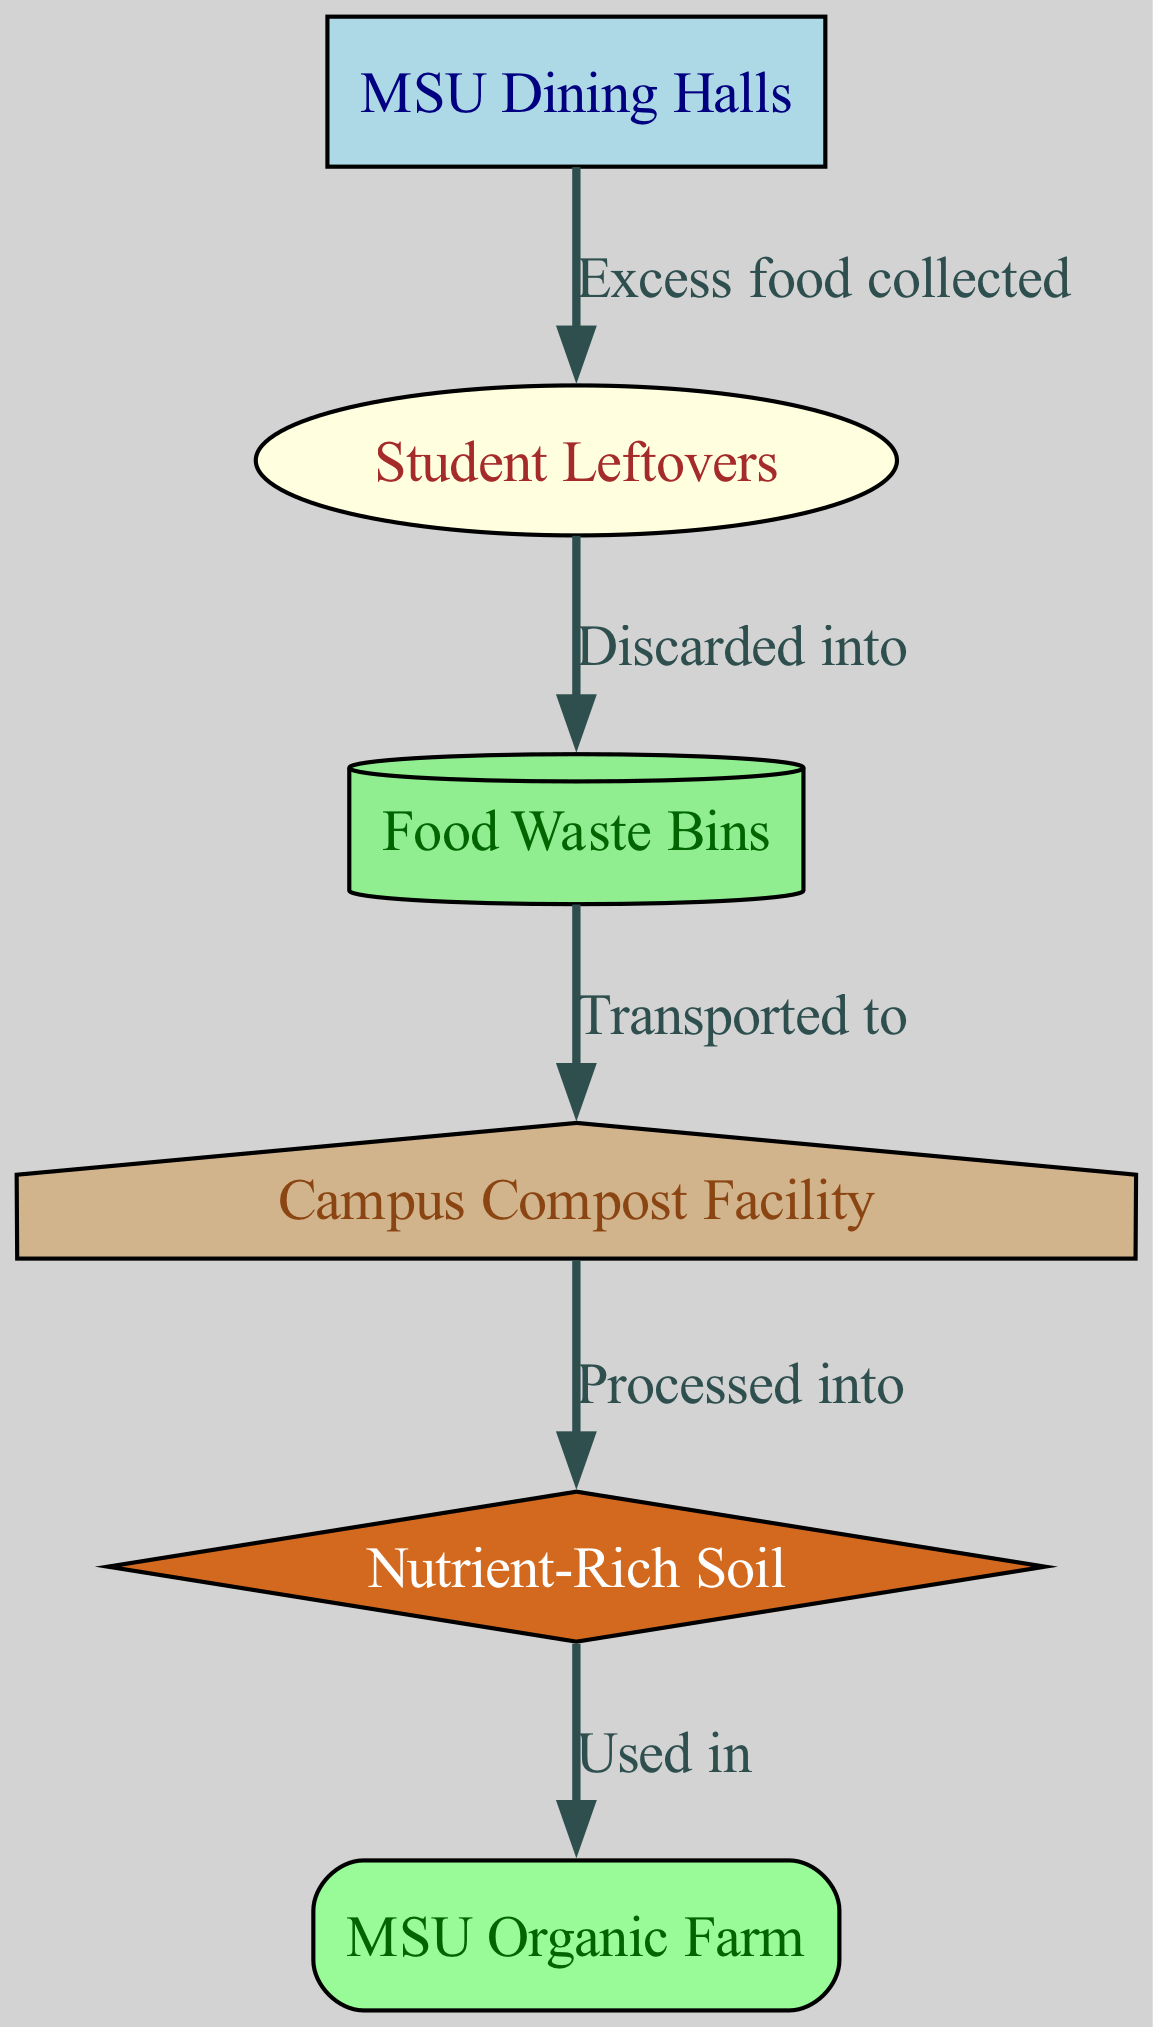What is the first node in the food waste cycle? The first node in the cycle is identified as the starting point of the diagram, which is labeled "MSU Dining Halls."
Answer: MSU Dining Halls How many nodes are present in the diagram? To determine the number of nodes, we count each unique location or step listed in the nodes section. There are six nodes: MSU Dining Halls, Student Leftovers, Food Waste Bins, Campus Compost Facility, Nutrient-Rich Soil, and MSU Organic Farm.
Answer: 6 What relationship occurs between "Student Leftovers" and "Food Waste Bins"? The relationship between "Student Leftovers" and "Food Waste Bins" is defined by the edge labeled "Discarded into," indicating that leftovers are disposed of in waste bins.
Answer: Discarded into Which node is processed to create "Nutrient-Rich Soil"? The node that is processed to create "Nutrient-Rich Soil" is the "Campus Compost Facility," as indicated by the flow that shows processing leads to the creation of nutrient-rich soil.
Answer: Campus Compost Facility What step follows after "Food Waste Bins"? After "Food Waste Bins," the next step indicated in the flow diagram is that the waste is "Transported to" the "Campus Compost Facility," which is the direct progression from the waste bins.
Answer: Transported to Which node utilizes "Nutrient-Rich Soil"? The node that utilizes "Nutrient-Rich Soil" is the "MSU Organic Farm," as represented in the final step of the diagram where the soil is used in farming.
Answer: MSU Organic Farm What is the relationship between "MSU Dining Halls" and "Student Leftovers"? The relationship established is "Excess food collected," indicating that the leftover food from the dining halls is collected as food waste.
Answer: Excess food collected How does "Campus Compost Facility" impact "MSU Organic Farm"? The impact is that "Nutrient-Rich Soil" is produced from the processing done in the "Campus Compost Facility," which is then used in the "MSU Organic Farm," highlighting the recycling of nutrients.
Answer: Used in How many edges are represented in the diagram? To find the number of edges, we count the connections between nodes. There are five edges: Excess food collected, Discarded into, Transported to, Processed into, and Used in.
Answer: 5 